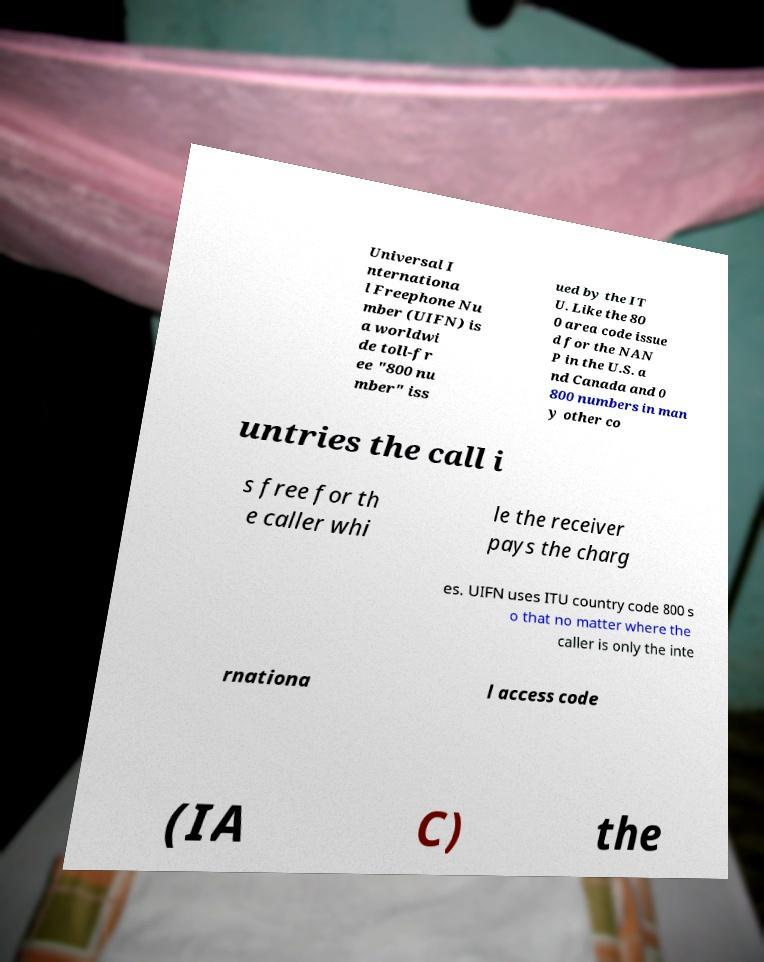Please read and relay the text visible in this image. What does it say? Universal I nternationa l Freephone Nu mber (UIFN) is a worldwi de toll-fr ee "800 nu mber" iss ued by the IT U. Like the 80 0 area code issue d for the NAN P in the U.S. a nd Canada and 0 800 numbers in man y other co untries the call i s free for th e caller whi le the receiver pays the charg es. UIFN uses ITU country code 800 s o that no matter where the caller is only the inte rnationa l access code (IA C) the 